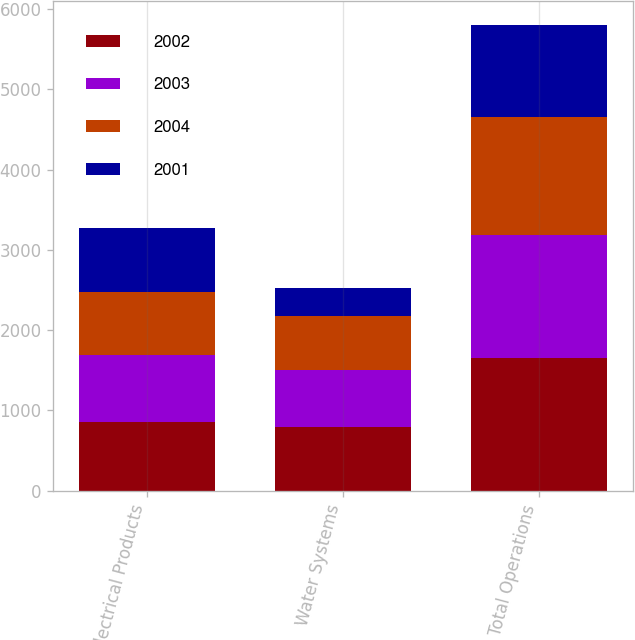Convert chart. <chart><loc_0><loc_0><loc_500><loc_500><stacked_bar_chart><ecel><fcel>Electrical Products<fcel>Water Systems<fcel>Total Operations<nl><fcel>2002<fcel>860.7<fcel>792.4<fcel>1653.1<nl><fcel>2003<fcel>824.6<fcel>706.1<fcel>1530.7<nl><fcel>2004<fcel>790.4<fcel>678.7<fcel>1469.1<nl><fcel>2001<fcel>802.7<fcel>348.5<fcel>1151.2<nl></chart> 